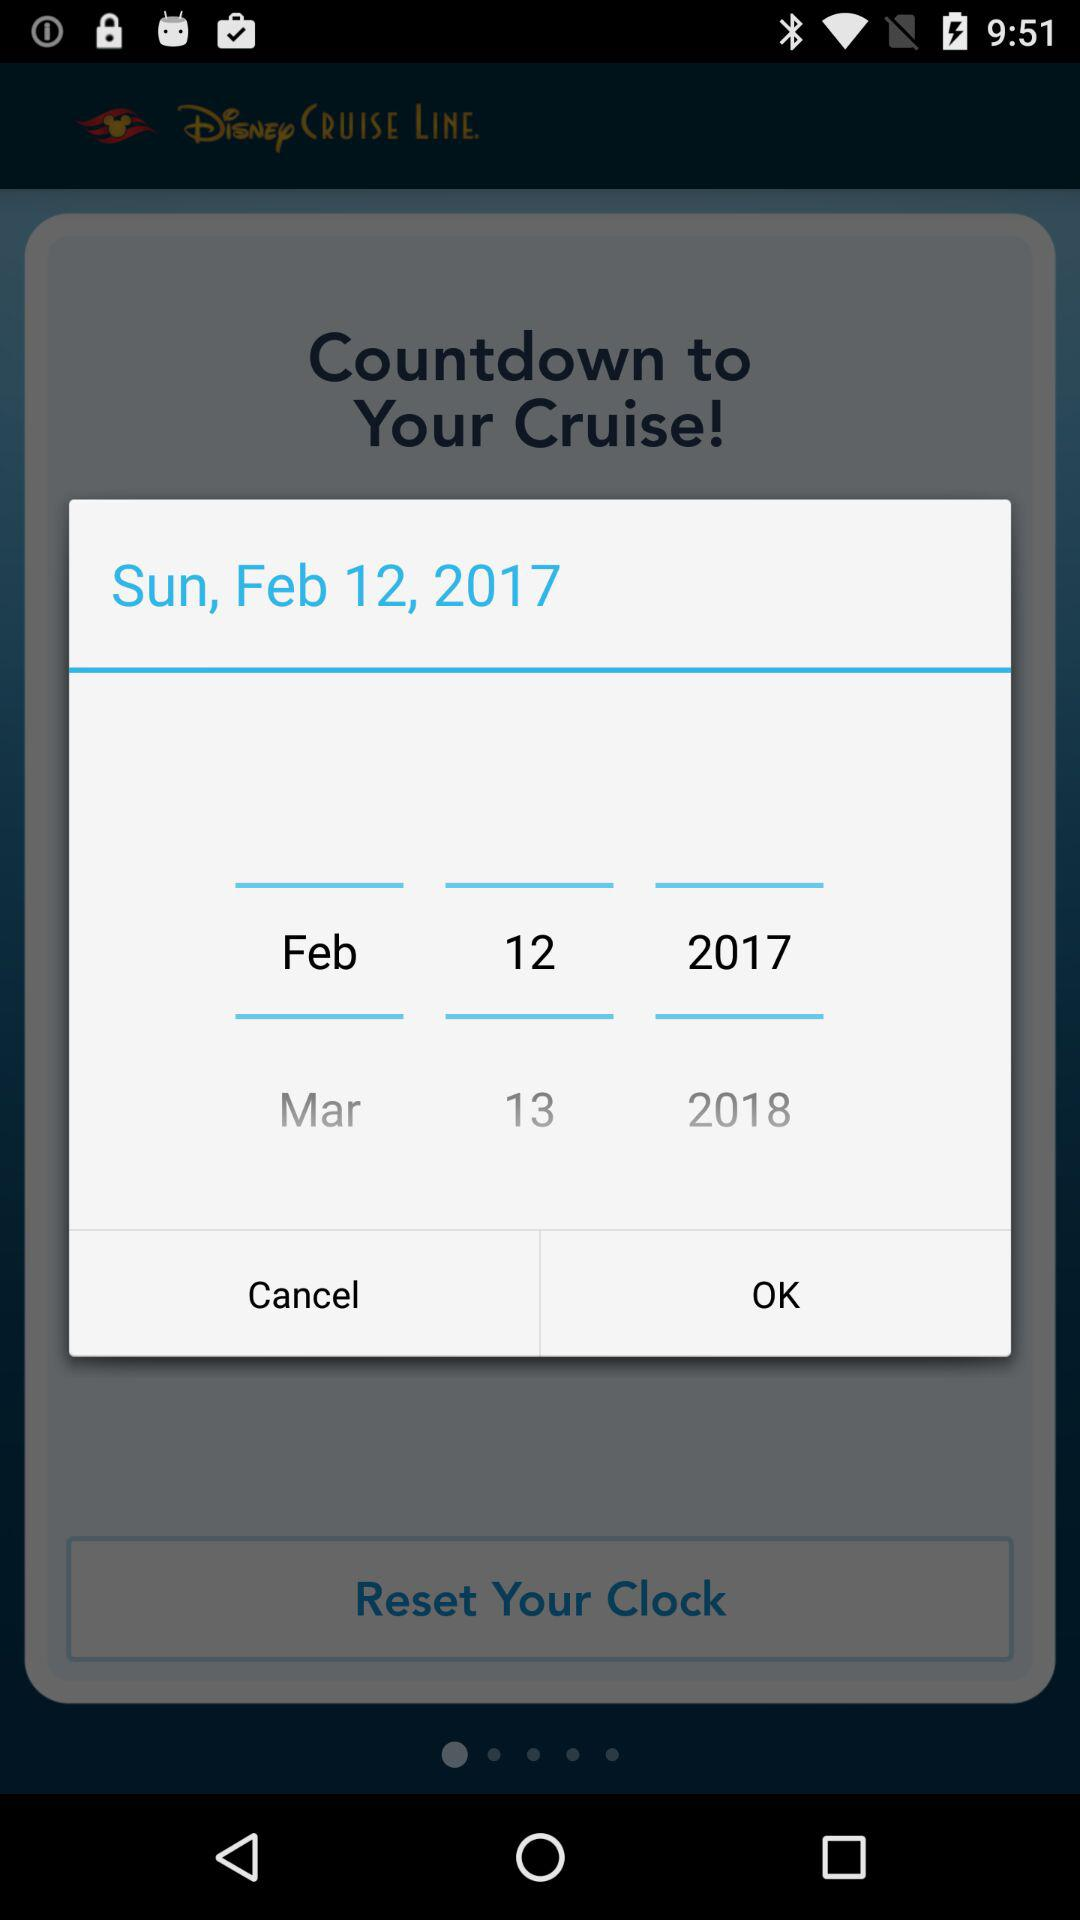How many years are represented on the screen?
Answer the question using a single word or phrase. 2 